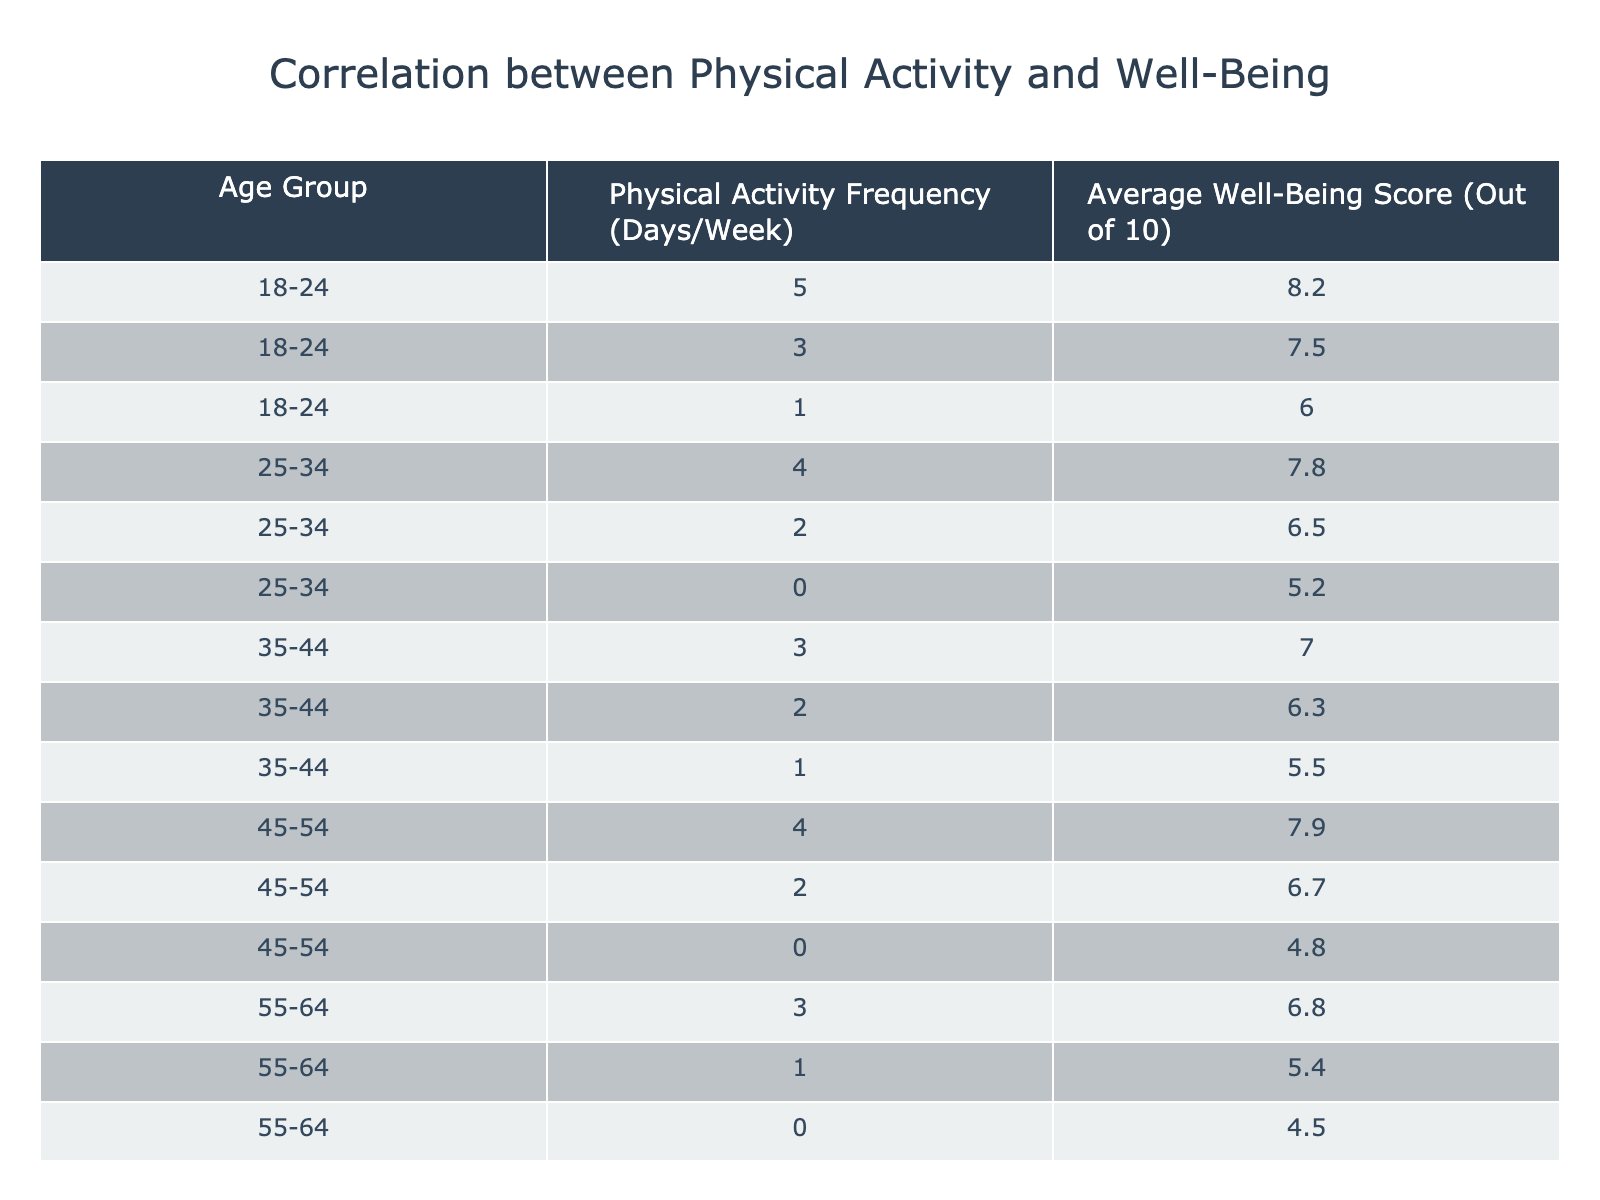What is the average well-being score for the age group 18-24? There are three well-being scores for the age group 18-24: 8.2, 7.5, and 6.0. To find the average, we add these scores: 8.2 + 7.5 + 6.0 = 21.7. Then, we divide by the number of entries (3): 21.7 / 3 = 7.23.
Answer: 7.23 What is the physical activity frequency associated with the highest average well-being score in the 45-54 age group? For the age group 45-54, the scores associated with their physical activity frequencies are as follows: 4 days per week with a score of 7.9, 2 days with a score of 6.7, and 0 days with a score of 4.8. The highest score here is 7.9, which corresponds to 4 days of physical activity per week.
Answer: 4 days What is the average well-being score across all age groups for individuals who engage in physical activity 0 days per week? There are three individuals who reported doing 0 days of physical activity across different age groups, with well-being scores of 5.2, 4.8, and 4.5. To find the average, we sum these scores: 5.2 + 4.8 + 4.5 = 14.5. Then, we divide by the number of entries (3): 14.5 / 3 = 4.83.
Answer: 4.83 Do individuals aged 65 and older report a higher average well-being score than those aged 55-64? For the age group 65 and older, the scores are 6.0, 4.9, and 3.8, which averages to (6.0 + 4.9 + 3.8) / 3 = 4.9. For 55-64, the scores are 6.8, 5.4, and 4.5, which averages to (6.8 + 5.4 + 4.5) / 3 = 5.23. Since 4.9 is less than 5.23, the statement is false.
Answer: No What is the trend in average well-being score as physical activity frequency increases across the age groups? Analyzing the data, for 0 days: 5.2, 4.8, 4.5; for 1 day: 6.0, 5.5, 5.4; for 2 days: 6.5, 6.3, 6.7, 6.0; for 3 days: 7.5, 7.0, 6.8; for 4 days: 8.2, 7.9; for 5 days: only one data point is 7.5. As we see, with increased physical activity, the average well-being score generally increases.
Answer: Average well-being increases with more physical activity 